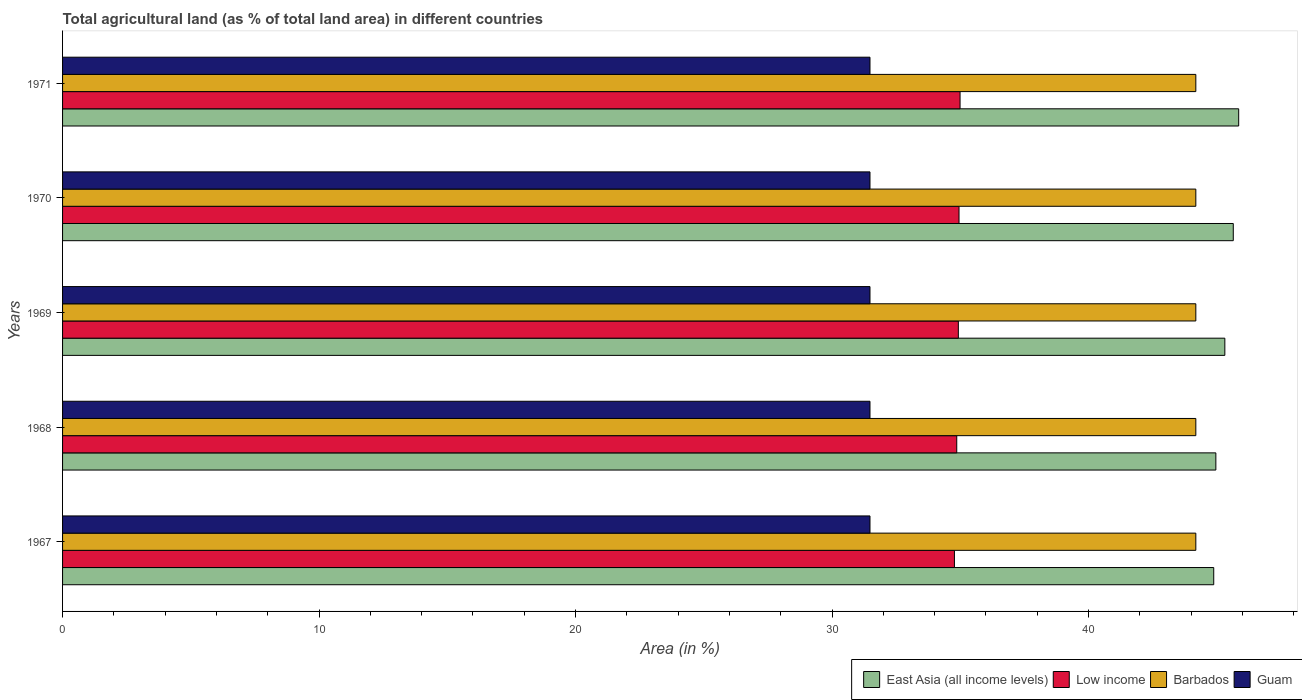How many groups of bars are there?
Give a very brief answer. 5. How many bars are there on the 4th tick from the top?
Make the answer very short. 4. How many bars are there on the 2nd tick from the bottom?
Offer a terse response. 4. What is the percentage of agricultural land in East Asia (all income levels) in 1969?
Ensure brevity in your answer.  45.32. Across all years, what is the maximum percentage of agricultural land in Guam?
Your answer should be very brief. 31.48. Across all years, what is the minimum percentage of agricultural land in East Asia (all income levels)?
Your answer should be very brief. 44.88. In which year was the percentage of agricultural land in Barbados maximum?
Provide a succinct answer. 1967. In which year was the percentage of agricultural land in Barbados minimum?
Keep it short and to the point. 1967. What is the total percentage of agricultural land in Guam in the graph?
Your answer should be very brief. 157.41. What is the difference between the percentage of agricultural land in Low income in 1968 and that in 1970?
Give a very brief answer. -0.09. What is the difference between the percentage of agricultural land in Guam in 1970 and the percentage of agricultural land in East Asia (all income levels) in 1969?
Offer a very short reply. -13.84. What is the average percentage of agricultural land in East Asia (all income levels) per year?
Your answer should be compact. 45.33. In the year 1968, what is the difference between the percentage of agricultural land in Barbados and percentage of agricultural land in Low income?
Provide a succinct answer. 9.32. In how many years, is the percentage of agricultural land in Barbados greater than 44 %?
Keep it short and to the point. 5. Is the percentage of agricultural land in Barbados in 1967 less than that in 1969?
Give a very brief answer. No. Is the difference between the percentage of agricultural land in Barbados in 1968 and 1969 greater than the difference between the percentage of agricultural land in Low income in 1968 and 1969?
Provide a short and direct response. Yes. What is the difference between the highest and the lowest percentage of agricultural land in East Asia (all income levels)?
Keep it short and to the point. 0.97. Is the sum of the percentage of agricultural land in East Asia (all income levels) in 1968 and 1971 greater than the maximum percentage of agricultural land in Guam across all years?
Your response must be concise. Yes. Is it the case that in every year, the sum of the percentage of agricultural land in East Asia (all income levels) and percentage of agricultural land in Barbados is greater than the sum of percentage of agricultural land in Low income and percentage of agricultural land in Guam?
Provide a short and direct response. Yes. What does the 3rd bar from the bottom in 1971 represents?
Provide a short and direct response. Barbados. How many bars are there?
Your answer should be very brief. 20. Does the graph contain any zero values?
Make the answer very short. No. Does the graph contain grids?
Your answer should be very brief. No. Where does the legend appear in the graph?
Offer a very short reply. Bottom right. What is the title of the graph?
Offer a terse response. Total agricultural land (as % of total land area) in different countries. What is the label or title of the X-axis?
Your answer should be compact. Area (in %). What is the label or title of the Y-axis?
Your answer should be compact. Years. What is the Area (in %) in East Asia (all income levels) in 1967?
Offer a terse response. 44.88. What is the Area (in %) of Low income in 1967?
Offer a very short reply. 34.77. What is the Area (in %) of Barbados in 1967?
Offer a terse response. 44.19. What is the Area (in %) of Guam in 1967?
Your response must be concise. 31.48. What is the Area (in %) in East Asia (all income levels) in 1968?
Make the answer very short. 44.97. What is the Area (in %) in Low income in 1968?
Provide a succinct answer. 34.86. What is the Area (in %) in Barbados in 1968?
Provide a succinct answer. 44.19. What is the Area (in %) in Guam in 1968?
Your answer should be very brief. 31.48. What is the Area (in %) in East Asia (all income levels) in 1969?
Your response must be concise. 45.32. What is the Area (in %) in Low income in 1969?
Provide a succinct answer. 34.93. What is the Area (in %) of Barbados in 1969?
Offer a very short reply. 44.19. What is the Area (in %) of Guam in 1969?
Your answer should be compact. 31.48. What is the Area (in %) in East Asia (all income levels) in 1970?
Offer a terse response. 45.65. What is the Area (in %) in Low income in 1970?
Your response must be concise. 34.95. What is the Area (in %) in Barbados in 1970?
Your answer should be very brief. 44.19. What is the Area (in %) in Guam in 1970?
Offer a terse response. 31.48. What is the Area (in %) in East Asia (all income levels) in 1971?
Your answer should be very brief. 45.86. What is the Area (in %) of Low income in 1971?
Your response must be concise. 34.99. What is the Area (in %) in Barbados in 1971?
Give a very brief answer. 44.19. What is the Area (in %) of Guam in 1971?
Ensure brevity in your answer.  31.48. Across all years, what is the maximum Area (in %) of East Asia (all income levels)?
Offer a terse response. 45.86. Across all years, what is the maximum Area (in %) of Low income?
Keep it short and to the point. 34.99. Across all years, what is the maximum Area (in %) in Barbados?
Provide a succinct answer. 44.19. Across all years, what is the maximum Area (in %) of Guam?
Provide a succinct answer. 31.48. Across all years, what is the minimum Area (in %) of East Asia (all income levels)?
Keep it short and to the point. 44.88. Across all years, what is the minimum Area (in %) in Low income?
Provide a succinct answer. 34.77. Across all years, what is the minimum Area (in %) of Barbados?
Offer a terse response. 44.19. Across all years, what is the minimum Area (in %) in Guam?
Give a very brief answer. 31.48. What is the total Area (in %) in East Asia (all income levels) in the graph?
Make the answer very short. 226.67. What is the total Area (in %) in Low income in the graph?
Provide a succinct answer. 174.51. What is the total Area (in %) of Barbados in the graph?
Offer a terse response. 220.93. What is the total Area (in %) of Guam in the graph?
Ensure brevity in your answer.  157.41. What is the difference between the Area (in %) in East Asia (all income levels) in 1967 and that in 1968?
Your answer should be very brief. -0.08. What is the difference between the Area (in %) of Low income in 1967 and that in 1968?
Give a very brief answer. -0.09. What is the difference between the Area (in %) of East Asia (all income levels) in 1967 and that in 1969?
Your answer should be compact. -0.43. What is the difference between the Area (in %) in Low income in 1967 and that in 1969?
Provide a succinct answer. -0.15. What is the difference between the Area (in %) of Guam in 1967 and that in 1969?
Give a very brief answer. 0. What is the difference between the Area (in %) in East Asia (all income levels) in 1967 and that in 1970?
Provide a short and direct response. -0.76. What is the difference between the Area (in %) in Low income in 1967 and that in 1970?
Your answer should be very brief. -0.18. What is the difference between the Area (in %) in Guam in 1967 and that in 1970?
Provide a succinct answer. 0. What is the difference between the Area (in %) of East Asia (all income levels) in 1967 and that in 1971?
Your answer should be compact. -0.97. What is the difference between the Area (in %) in Low income in 1967 and that in 1971?
Provide a succinct answer. -0.22. What is the difference between the Area (in %) in Barbados in 1967 and that in 1971?
Give a very brief answer. 0. What is the difference between the Area (in %) of East Asia (all income levels) in 1968 and that in 1969?
Make the answer very short. -0.35. What is the difference between the Area (in %) in Low income in 1968 and that in 1969?
Offer a very short reply. -0.06. What is the difference between the Area (in %) in East Asia (all income levels) in 1968 and that in 1970?
Make the answer very short. -0.68. What is the difference between the Area (in %) in Low income in 1968 and that in 1970?
Provide a short and direct response. -0.09. What is the difference between the Area (in %) of Barbados in 1968 and that in 1970?
Your answer should be very brief. 0. What is the difference between the Area (in %) in East Asia (all income levels) in 1968 and that in 1971?
Offer a terse response. -0.89. What is the difference between the Area (in %) of Low income in 1968 and that in 1971?
Give a very brief answer. -0.13. What is the difference between the Area (in %) of Guam in 1968 and that in 1971?
Offer a very short reply. 0. What is the difference between the Area (in %) of East Asia (all income levels) in 1969 and that in 1970?
Provide a short and direct response. -0.33. What is the difference between the Area (in %) of Low income in 1969 and that in 1970?
Your answer should be compact. -0.03. What is the difference between the Area (in %) in East Asia (all income levels) in 1969 and that in 1971?
Offer a terse response. -0.54. What is the difference between the Area (in %) in Low income in 1969 and that in 1971?
Provide a short and direct response. -0.07. What is the difference between the Area (in %) in Guam in 1969 and that in 1971?
Offer a terse response. 0. What is the difference between the Area (in %) in East Asia (all income levels) in 1970 and that in 1971?
Ensure brevity in your answer.  -0.21. What is the difference between the Area (in %) in Low income in 1970 and that in 1971?
Make the answer very short. -0.04. What is the difference between the Area (in %) in East Asia (all income levels) in 1967 and the Area (in %) in Low income in 1968?
Give a very brief answer. 10.02. What is the difference between the Area (in %) of East Asia (all income levels) in 1967 and the Area (in %) of Barbados in 1968?
Your answer should be compact. 0.7. What is the difference between the Area (in %) in East Asia (all income levels) in 1967 and the Area (in %) in Guam in 1968?
Keep it short and to the point. 13.4. What is the difference between the Area (in %) of Low income in 1967 and the Area (in %) of Barbados in 1968?
Keep it short and to the point. -9.41. What is the difference between the Area (in %) in Low income in 1967 and the Area (in %) in Guam in 1968?
Offer a terse response. 3.29. What is the difference between the Area (in %) of Barbados in 1967 and the Area (in %) of Guam in 1968?
Provide a succinct answer. 12.7. What is the difference between the Area (in %) in East Asia (all income levels) in 1967 and the Area (in %) in Low income in 1969?
Your response must be concise. 9.96. What is the difference between the Area (in %) of East Asia (all income levels) in 1967 and the Area (in %) of Barbados in 1969?
Your answer should be compact. 0.7. What is the difference between the Area (in %) of East Asia (all income levels) in 1967 and the Area (in %) of Guam in 1969?
Make the answer very short. 13.4. What is the difference between the Area (in %) of Low income in 1967 and the Area (in %) of Barbados in 1969?
Your response must be concise. -9.41. What is the difference between the Area (in %) in Low income in 1967 and the Area (in %) in Guam in 1969?
Give a very brief answer. 3.29. What is the difference between the Area (in %) of Barbados in 1967 and the Area (in %) of Guam in 1969?
Provide a succinct answer. 12.7. What is the difference between the Area (in %) in East Asia (all income levels) in 1967 and the Area (in %) in Low income in 1970?
Ensure brevity in your answer.  9.93. What is the difference between the Area (in %) of East Asia (all income levels) in 1967 and the Area (in %) of Barbados in 1970?
Your response must be concise. 0.7. What is the difference between the Area (in %) of East Asia (all income levels) in 1967 and the Area (in %) of Guam in 1970?
Your response must be concise. 13.4. What is the difference between the Area (in %) in Low income in 1967 and the Area (in %) in Barbados in 1970?
Keep it short and to the point. -9.41. What is the difference between the Area (in %) of Low income in 1967 and the Area (in %) of Guam in 1970?
Your answer should be compact. 3.29. What is the difference between the Area (in %) in Barbados in 1967 and the Area (in %) in Guam in 1970?
Your response must be concise. 12.7. What is the difference between the Area (in %) in East Asia (all income levels) in 1967 and the Area (in %) in Low income in 1971?
Give a very brief answer. 9.89. What is the difference between the Area (in %) of East Asia (all income levels) in 1967 and the Area (in %) of Barbados in 1971?
Offer a very short reply. 0.7. What is the difference between the Area (in %) of East Asia (all income levels) in 1967 and the Area (in %) of Guam in 1971?
Keep it short and to the point. 13.4. What is the difference between the Area (in %) in Low income in 1967 and the Area (in %) in Barbados in 1971?
Give a very brief answer. -9.41. What is the difference between the Area (in %) of Low income in 1967 and the Area (in %) of Guam in 1971?
Your answer should be compact. 3.29. What is the difference between the Area (in %) in Barbados in 1967 and the Area (in %) in Guam in 1971?
Make the answer very short. 12.7. What is the difference between the Area (in %) of East Asia (all income levels) in 1968 and the Area (in %) of Low income in 1969?
Offer a terse response. 10.04. What is the difference between the Area (in %) in East Asia (all income levels) in 1968 and the Area (in %) in Barbados in 1969?
Offer a terse response. 0.78. What is the difference between the Area (in %) in East Asia (all income levels) in 1968 and the Area (in %) in Guam in 1969?
Give a very brief answer. 13.49. What is the difference between the Area (in %) of Low income in 1968 and the Area (in %) of Barbados in 1969?
Offer a very short reply. -9.32. What is the difference between the Area (in %) in Low income in 1968 and the Area (in %) in Guam in 1969?
Ensure brevity in your answer.  3.38. What is the difference between the Area (in %) of Barbados in 1968 and the Area (in %) of Guam in 1969?
Offer a very short reply. 12.7. What is the difference between the Area (in %) in East Asia (all income levels) in 1968 and the Area (in %) in Low income in 1970?
Provide a short and direct response. 10.01. What is the difference between the Area (in %) in East Asia (all income levels) in 1968 and the Area (in %) in Barbados in 1970?
Offer a terse response. 0.78. What is the difference between the Area (in %) in East Asia (all income levels) in 1968 and the Area (in %) in Guam in 1970?
Give a very brief answer. 13.49. What is the difference between the Area (in %) in Low income in 1968 and the Area (in %) in Barbados in 1970?
Keep it short and to the point. -9.32. What is the difference between the Area (in %) in Low income in 1968 and the Area (in %) in Guam in 1970?
Offer a terse response. 3.38. What is the difference between the Area (in %) of Barbados in 1968 and the Area (in %) of Guam in 1970?
Make the answer very short. 12.7. What is the difference between the Area (in %) in East Asia (all income levels) in 1968 and the Area (in %) in Low income in 1971?
Make the answer very short. 9.97. What is the difference between the Area (in %) in East Asia (all income levels) in 1968 and the Area (in %) in Barbados in 1971?
Keep it short and to the point. 0.78. What is the difference between the Area (in %) in East Asia (all income levels) in 1968 and the Area (in %) in Guam in 1971?
Keep it short and to the point. 13.49. What is the difference between the Area (in %) of Low income in 1968 and the Area (in %) of Barbados in 1971?
Give a very brief answer. -9.32. What is the difference between the Area (in %) of Low income in 1968 and the Area (in %) of Guam in 1971?
Your answer should be compact. 3.38. What is the difference between the Area (in %) in Barbados in 1968 and the Area (in %) in Guam in 1971?
Your answer should be compact. 12.7. What is the difference between the Area (in %) in East Asia (all income levels) in 1969 and the Area (in %) in Low income in 1970?
Your answer should be very brief. 10.36. What is the difference between the Area (in %) in East Asia (all income levels) in 1969 and the Area (in %) in Barbados in 1970?
Offer a terse response. 1.13. What is the difference between the Area (in %) in East Asia (all income levels) in 1969 and the Area (in %) in Guam in 1970?
Keep it short and to the point. 13.84. What is the difference between the Area (in %) of Low income in 1969 and the Area (in %) of Barbados in 1970?
Provide a succinct answer. -9.26. What is the difference between the Area (in %) of Low income in 1969 and the Area (in %) of Guam in 1970?
Make the answer very short. 3.44. What is the difference between the Area (in %) of Barbados in 1969 and the Area (in %) of Guam in 1970?
Your answer should be compact. 12.7. What is the difference between the Area (in %) of East Asia (all income levels) in 1969 and the Area (in %) of Low income in 1971?
Provide a short and direct response. 10.32. What is the difference between the Area (in %) of East Asia (all income levels) in 1969 and the Area (in %) of Barbados in 1971?
Your answer should be very brief. 1.13. What is the difference between the Area (in %) of East Asia (all income levels) in 1969 and the Area (in %) of Guam in 1971?
Offer a terse response. 13.84. What is the difference between the Area (in %) in Low income in 1969 and the Area (in %) in Barbados in 1971?
Offer a very short reply. -9.26. What is the difference between the Area (in %) in Low income in 1969 and the Area (in %) in Guam in 1971?
Offer a very short reply. 3.44. What is the difference between the Area (in %) in Barbados in 1969 and the Area (in %) in Guam in 1971?
Your answer should be very brief. 12.7. What is the difference between the Area (in %) in East Asia (all income levels) in 1970 and the Area (in %) in Low income in 1971?
Ensure brevity in your answer.  10.65. What is the difference between the Area (in %) of East Asia (all income levels) in 1970 and the Area (in %) of Barbados in 1971?
Your answer should be compact. 1.46. What is the difference between the Area (in %) of East Asia (all income levels) in 1970 and the Area (in %) of Guam in 1971?
Ensure brevity in your answer.  14.16. What is the difference between the Area (in %) in Low income in 1970 and the Area (in %) in Barbados in 1971?
Give a very brief answer. -9.23. What is the difference between the Area (in %) in Low income in 1970 and the Area (in %) in Guam in 1971?
Provide a short and direct response. 3.47. What is the difference between the Area (in %) of Barbados in 1970 and the Area (in %) of Guam in 1971?
Provide a succinct answer. 12.7. What is the average Area (in %) of East Asia (all income levels) per year?
Ensure brevity in your answer.  45.33. What is the average Area (in %) of Low income per year?
Your response must be concise. 34.9. What is the average Area (in %) of Barbados per year?
Make the answer very short. 44.19. What is the average Area (in %) of Guam per year?
Offer a very short reply. 31.48. In the year 1967, what is the difference between the Area (in %) in East Asia (all income levels) and Area (in %) in Low income?
Keep it short and to the point. 10.11. In the year 1967, what is the difference between the Area (in %) of East Asia (all income levels) and Area (in %) of Barbados?
Offer a terse response. 0.7. In the year 1967, what is the difference between the Area (in %) in East Asia (all income levels) and Area (in %) in Guam?
Provide a short and direct response. 13.4. In the year 1967, what is the difference between the Area (in %) in Low income and Area (in %) in Barbados?
Offer a very short reply. -9.41. In the year 1967, what is the difference between the Area (in %) in Low income and Area (in %) in Guam?
Provide a succinct answer. 3.29. In the year 1967, what is the difference between the Area (in %) of Barbados and Area (in %) of Guam?
Provide a short and direct response. 12.7. In the year 1968, what is the difference between the Area (in %) in East Asia (all income levels) and Area (in %) in Low income?
Make the answer very short. 10.1. In the year 1968, what is the difference between the Area (in %) in East Asia (all income levels) and Area (in %) in Barbados?
Make the answer very short. 0.78. In the year 1968, what is the difference between the Area (in %) of East Asia (all income levels) and Area (in %) of Guam?
Your answer should be compact. 13.49. In the year 1968, what is the difference between the Area (in %) of Low income and Area (in %) of Barbados?
Offer a terse response. -9.32. In the year 1968, what is the difference between the Area (in %) in Low income and Area (in %) in Guam?
Offer a very short reply. 3.38. In the year 1968, what is the difference between the Area (in %) of Barbados and Area (in %) of Guam?
Keep it short and to the point. 12.7. In the year 1969, what is the difference between the Area (in %) in East Asia (all income levels) and Area (in %) in Low income?
Ensure brevity in your answer.  10.39. In the year 1969, what is the difference between the Area (in %) of East Asia (all income levels) and Area (in %) of Barbados?
Offer a terse response. 1.13. In the year 1969, what is the difference between the Area (in %) in East Asia (all income levels) and Area (in %) in Guam?
Your answer should be compact. 13.84. In the year 1969, what is the difference between the Area (in %) in Low income and Area (in %) in Barbados?
Give a very brief answer. -9.26. In the year 1969, what is the difference between the Area (in %) in Low income and Area (in %) in Guam?
Provide a short and direct response. 3.44. In the year 1969, what is the difference between the Area (in %) of Barbados and Area (in %) of Guam?
Your answer should be compact. 12.7. In the year 1970, what is the difference between the Area (in %) of East Asia (all income levels) and Area (in %) of Low income?
Your answer should be compact. 10.69. In the year 1970, what is the difference between the Area (in %) of East Asia (all income levels) and Area (in %) of Barbados?
Keep it short and to the point. 1.46. In the year 1970, what is the difference between the Area (in %) of East Asia (all income levels) and Area (in %) of Guam?
Ensure brevity in your answer.  14.16. In the year 1970, what is the difference between the Area (in %) of Low income and Area (in %) of Barbados?
Provide a succinct answer. -9.23. In the year 1970, what is the difference between the Area (in %) in Low income and Area (in %) in Guam?
Make the answer very short. 3.47. In the year 1970, what is the difference between the Area (in %) in Barbados and Area (in %) in Guam?
Your response must be concise. 12.7. In the year 1971, what is the difference between the Area (in %) of East Asia (all income levels) and Area (in %) of Low income?
Your response must be concise. 10.86. In the year 1971, what is the difference between the Area (in %) of East Asia (all income levels) and Area (in %) of Barbados?
Make the answer very short. 1.67. In the year 1971, what is the difference between the Area (in %) of East Asia (all income levels) and Area (in %) of Guam?
Keep it short and to the point. 14.38. In the year 1971, what is the difference between the Area (in %) in Low income and Area (in %) in Barbados?
Make the answer very short. -9.19. In the year 1971, what is the difference between the Area (in %) of Low income and Area (in %) of Guam?
Your answer should be compact. 3.51. In the year 1971, what is the difference between the Area (in %) of Barbados and Area (in %) of Guam?
Your answer should be compact. 12.7. What is the ratio of the Area (in %) in Low income in 1967 to that in 1968?
Your response must be concise. 1. What is the ratio of the Area (in %) in Barbados in 1967 to that in 1968?
Offer a terse response. 1. What is the ratio of the Area (in %) of Guam in 1967 to that in 1968?
Ensure brevity in your answer.  1. What is the ratio of the Area (in %) of East Asia (all income levels) in 1967 to that in 1969?
Offer a terse response. 0.99. What is the ratio of the Area (in %) of Low income in 1967 to that in 1969?
Your answer should be very brief. 1. What is the ratio of the Area (in %) in East Asia (all income levels) in 1967 to that in 1970?
Offer a very short reply. 0.98. What is the ratio of the Area (in %) of Barbados in 1967 to that in 1970?
Offer a terse response. 1. What is the ratio of the Area (in %) of Guam in 1967 to that in 1970?
Make the answer very short. 1. What is the ratio of the Area (in %) in East Asia (all income levels) in 1967 to that in 1971?
Your response must be concise. 0.98. What is the ratio of the Area (in %) in Barbados in 1967 to that in 1971?
Offer a terse response. 1. What is the ratio of the Area (in %) in Guam in 1967 to that in 1971?
Make the answer very short. 1. What is the ratio of the Area (in %) in East Asia (all income levels) in 1968 to that in 1969?
Offer a terse response. 0.99. What is the ratio of the Area (in %) in Barbados in 1968 to that in 1969?
Ensure brevity in your answer.  1. What is the ratio of the Area (in %) of Guam in 1968 to that in 1969?
Make the answer very short. 1. What is the ratio of the Area (in %) in East Asia (all income levels) in 1968 to that in 1970?
Offer a terse response. 0.99. What is the ratio of the Area (in %) in Barbados in 1968 to that in 1970?
Your answer should be very brief. 1. What is the ratio of the Area (in %) in East Asia (all income levels) in 1968 to that in 1971?
Offer a terse response. 0.98. What is the ratio of the Area (in %) in Low income in 1968 to that in 1971?
Your answer should be compact. 1. What is the ratio of the Area (in %) in Guam in 1968 to that in 1971?
Your answer should be very brief. 1. What is the ratio of the Area (in %) of Low income in 1969 to that in 1971?
Provide a short and direct response. 1. What is the ratio of the Area (in %) of Guam in 1970 to that in 1971?
Ensure brevity in your answer.  1. What is the difference between the highest and the second highest Area (in %) of East Asia (all income levels)?
Make the answer very short. 0.21. What is the difference between the highest and the second highest Area (in %) of Low income?
Provide a short and direct response. 0.04. What is the difference between the highest and the lowest Area (in %) of East Asia (all income levels)?
Offer a very short reply. 0.97. What is the difference between the highest and the lowest Area (in %) of Low income?
Give a very brief answer. 0.22. 